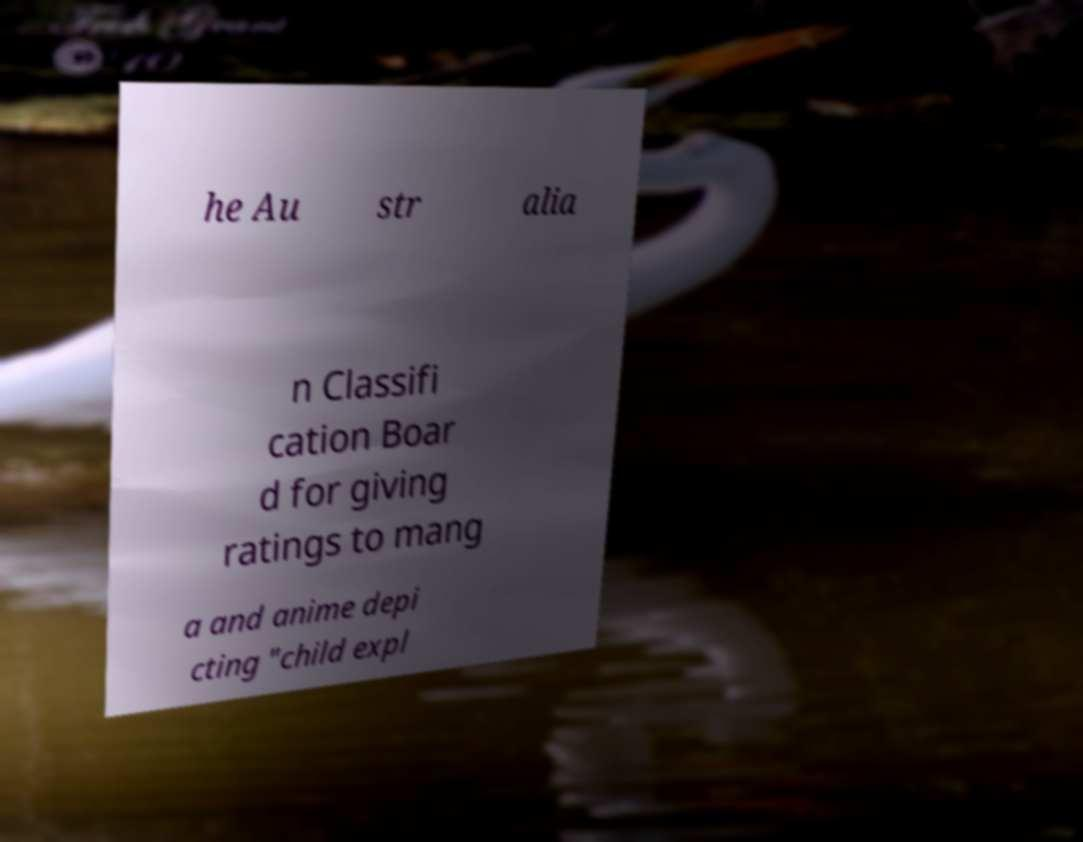Could you assist in decoding the text presented in this image and type it out clearly? he Au str alia n Classifi cation Boar d for giving ratings to mang a and anime depi cting "child expl 